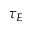<formula> <loc_0><loc_0><loc_500><loc_500>\tau _ { E }</formula> 